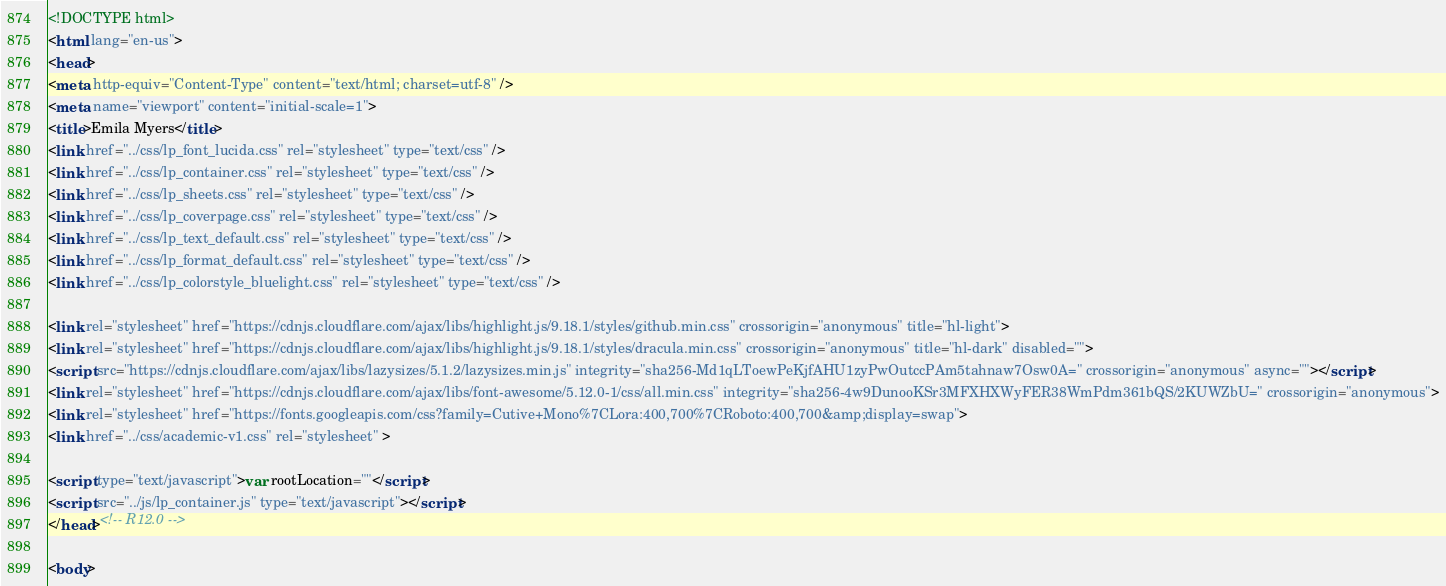Convert code to text. <code><loc_0><loc_0><loc_500><loc_500><_HTML_><!DOCTYPE html>
<html lang="en-us">
<head>
<meta http-equiv="Content-Type" content="text/html; charset=utf-8" />
<meta name="viewport" content="initial-scale=1">
<title>Emila Myers</title>
<link href="../css/lp_font_lucida.css" rel="stylesheet" type="text/css" />
<link href="../css/lp_container.css" rel="stylesheet" type="text/css" />
<link href="../css/lp_sheets.css" rel="stylesheet" type="text/css" />
<link href="../css/lp_coverpage.css" rel="stylesheet" type="text/css" />
<link href="../css/lp_text_default.css" rel="stylesheet" type="text/css" />
<link href="../css/lp_format_default.css" rel="stylesheet" type="text/css" />
<link href="../css/lp_colorstyle_bluelight.css" rel="stylesheet" type="text/css" />

<link rel="stylesheet" href="https://cdnjs.cloudflare.com/ajax/libs/highlight.js/9.18.1/styles/github.min.css" crossorigin="anonymous" title="hl-light">
<link rel="stylesheet" href="https://cdnjs.cloudflare.com/ajax/libs/highlight.js/9.18.1/styles/dracula.min.css" crossorigin="anonymous" title="hl-dark" disabled="">
<script src="https://cdnjs.cloudflare.com/ajax/libs/lazysizes/5.1.2/lazysizes.min.js" integrity="sha256-Md1qLToewPeKjfAHU1zyPwOutccPAm5tahnaw7Osw0A=" crossorigin="anonymous" async=""></script>
<link rel="stylesheet" href="https://cdnjs.cloudflare.com/ajax/libs/font-awesome/5.12.0-1/css/all.min.css" integrity="sha256-4w9DunooKSr3MFXHXWyFER38WmPdm361bQS/2KUWZbU=" crossorigin="anonymous">
<link rel="stylesheet" href="https://fonts.googleapis.com/css?family=Cutive+Mono%7CLora:400,700%7CRoboto:400,700&amp;display=swap">
<link href="../css/academic-v1.css" rel="stylesheet" >

<script type="text/javascript">var rootLocation=""</script>
<script src="../js/lp_container.js" type="text/javascript"></script>
</head><!-- R12.0 -->

<body></code> 